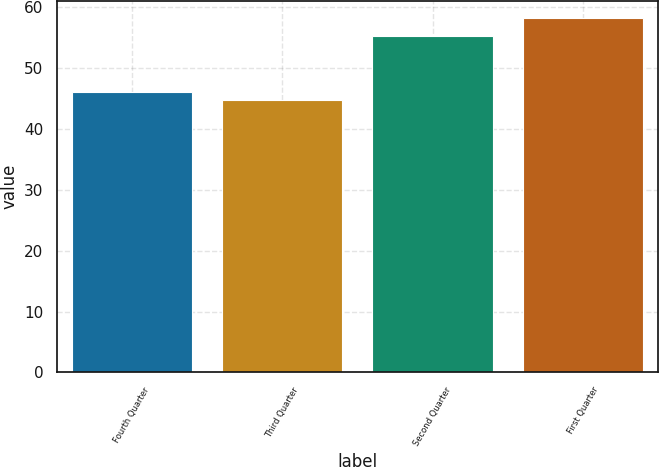Convert chart. <chart><loc_0><loc_0><loc_500><loc_500><bar_chart><fcel>Fourth Quarter<fcel>Third Quarter<fcel>Second Quarter<fcel>First Quarter<nl><fcel>46.05<fcel>44.7<fcel>55.25<fcel>58.19<nl></chart> 